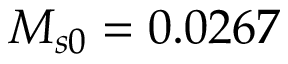Convert formula to latex. <formula><loc_0><loc_0><loc_500><loc_500>M _ { s 0 } = 0 . 0 2 6 7</formula> 